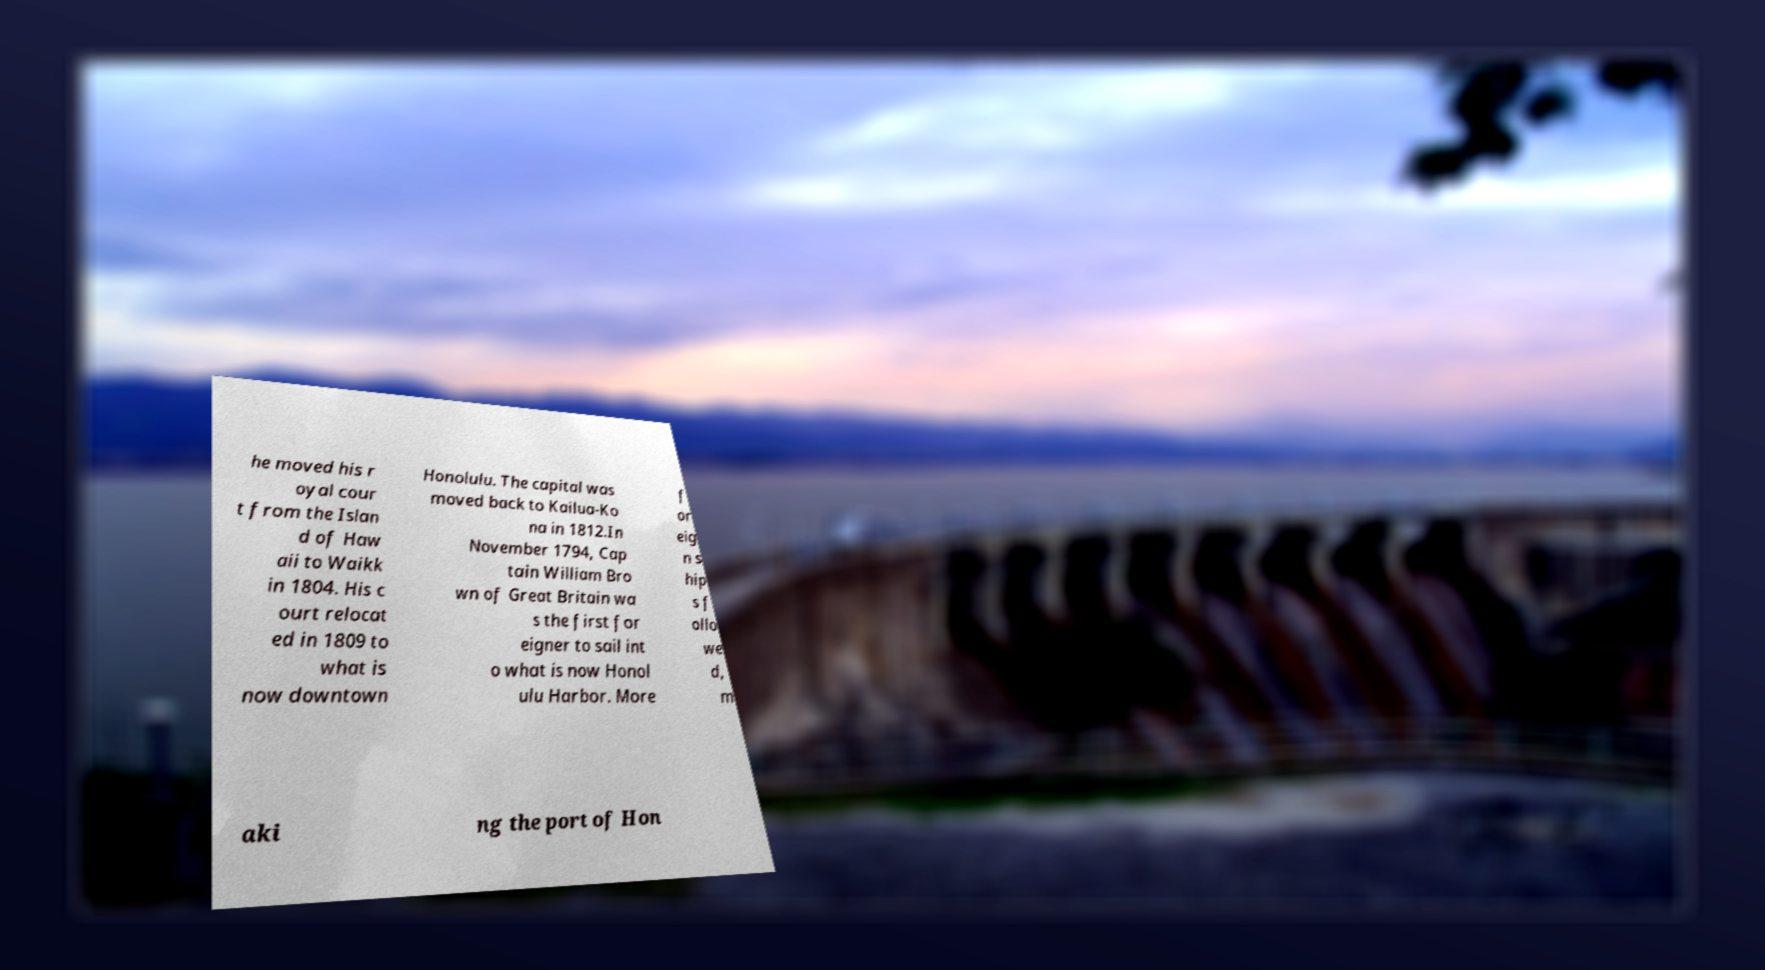What messages or text are displayed in this image? I need them in a readable, typed format. he moved his r oyal cour t from the Islan d of Haw aii to Waikk in 1804. His c ourt relocat ed in 1809 to what is now downtown Honolulu. The capital was moved back to Kailua-Ko na in 1812.In November 1794, Cap tain William Bro wn of Great Britain wa s the first for eigner to sail int o what is now Honol ulu Harbor. More f or eig n s hip s f ollo we d, m aki ng the port of Hon 